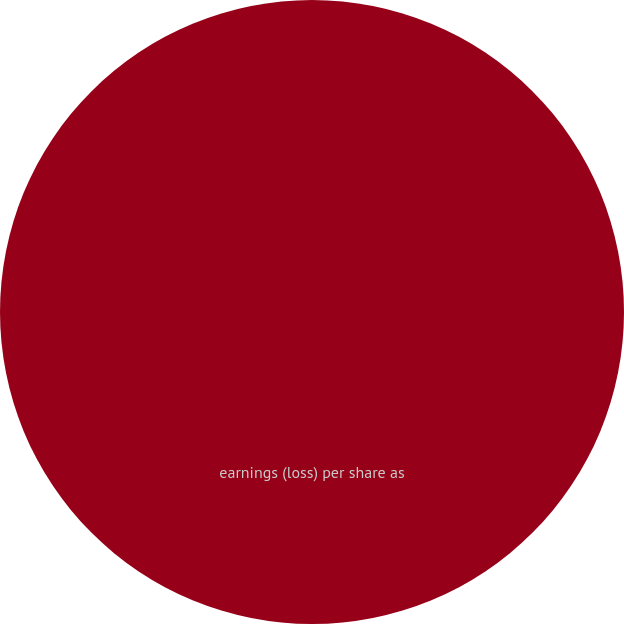Convert chart. <chart><loc_0><loc_0><loc_500><loc_500><pie_chart><fcel>earnings (loss) per share as<nl><fcel>100.0%<nl></chart> 